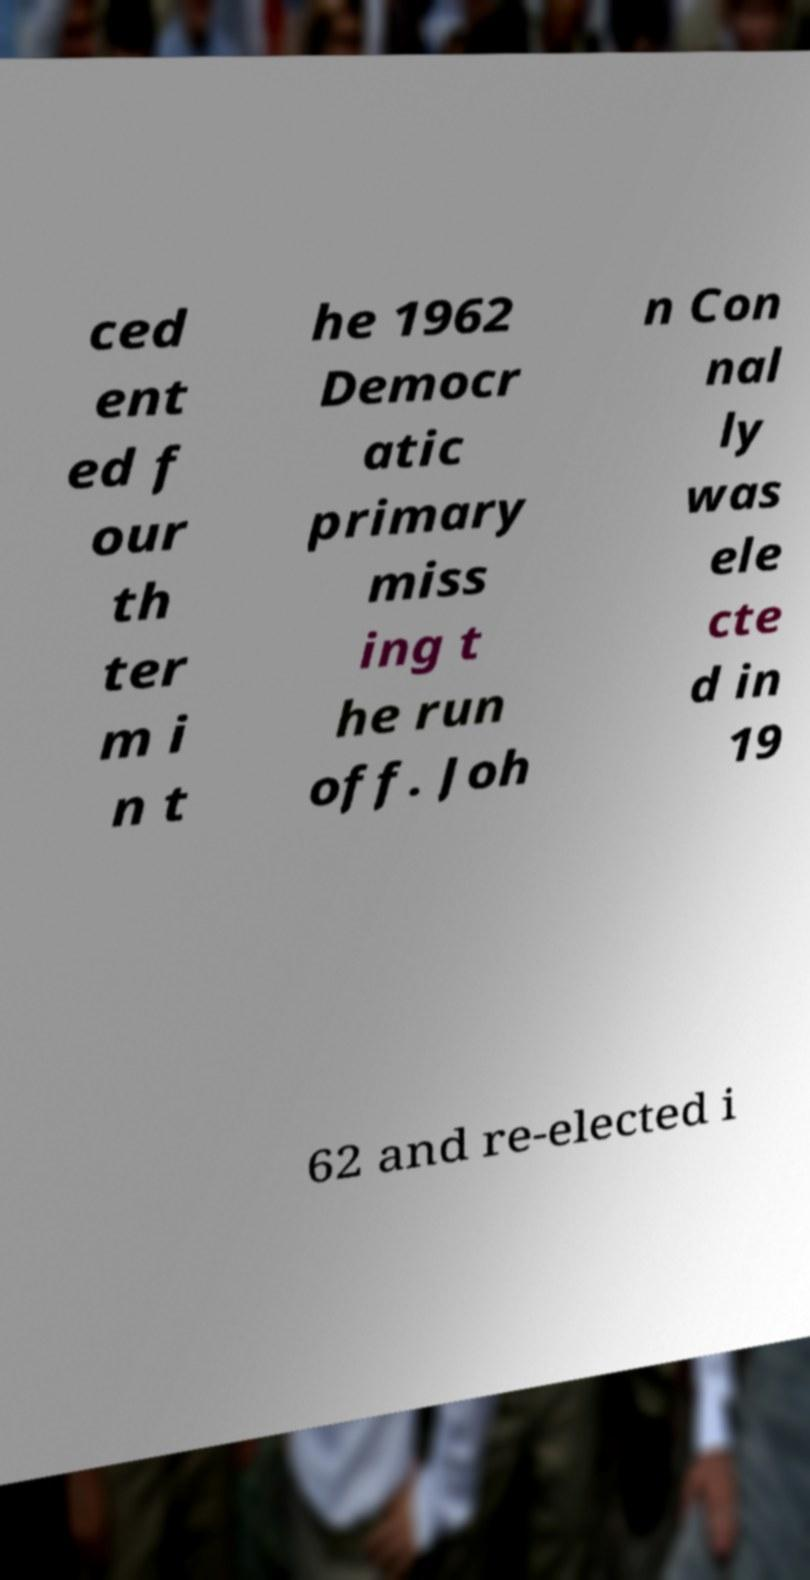Can you read and provide the text displayed in the image?This photo seems to have some interesting text. Can you extract and type it out for me? ced ent ed f our th ter m i n t he 1962 Democr atic primary miss ing t he run off. Joh n Con nal ly was ele cte d in 19 62 and re-elected i 